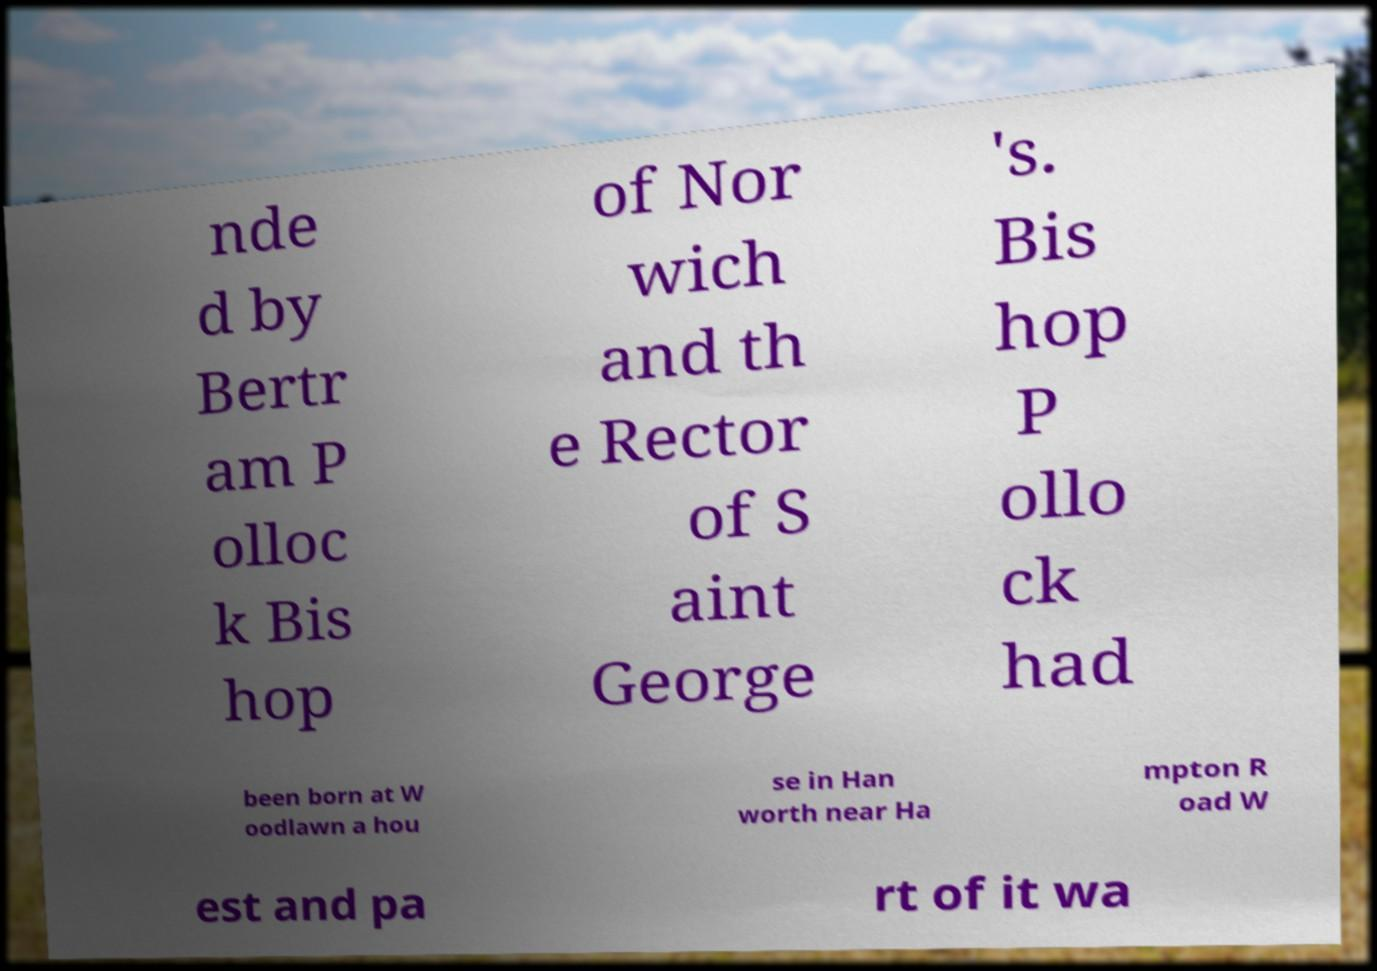There's text embedded in this image that I need extracted. Can you transcribe it verbatim? nde d by Bertr am P olloc k Bis hop of Nor wich and th e Rector of S aint George 's. Bis hop P ollo ck had been born at W oodlawn a hou se in Han worth near Ha mpton R oad W est and pa rt of it wa 